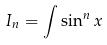Convert formula to latex. <formula><loc_0><loc_0><loc_500><loc_500>I _ { n } = \int \sin ^ { n } x</formula> 